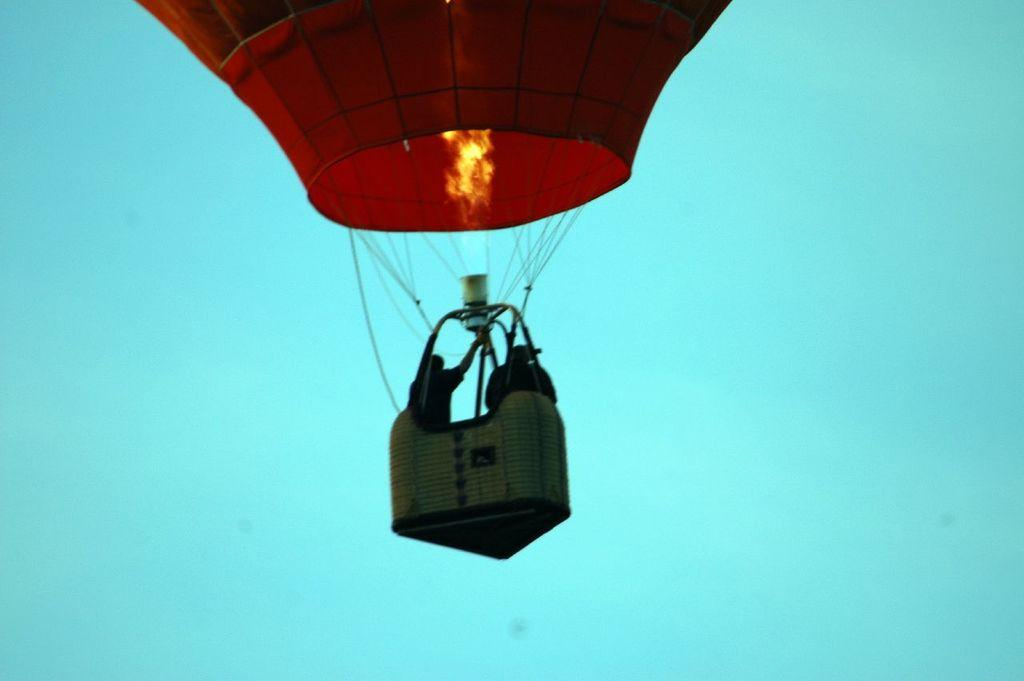What is the main subject of the image? The main subject of the image is persons in an air balloon. Where is the air balloon located in the image? The air balloon is in the center of the image. What can be seen in the background of the image? The sky is visible in the background of the image. What is the price of the soap in the image? There is no soap present in the image, so it is not possible to determine its price. 